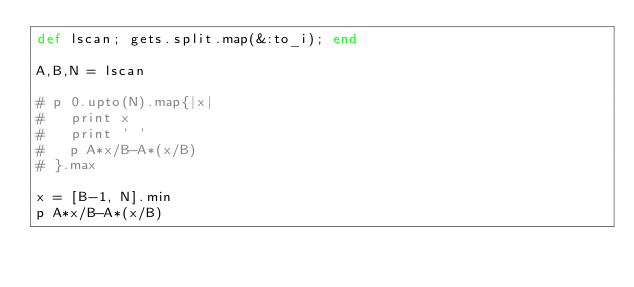Convert code to text. <code><loc_0><loc_0><loc_500><loc_500><_Ruby_>def lscan; gets.split.map(&:to_i); end

A,B,N = lscan

# p 0.upto(N).map{|x|
#   print x
#   print ' '
#   p A*x/B-A*(x/B)
# }.max

x = [B-1, N].min
p A*x/B-A*(x/B)</code> 